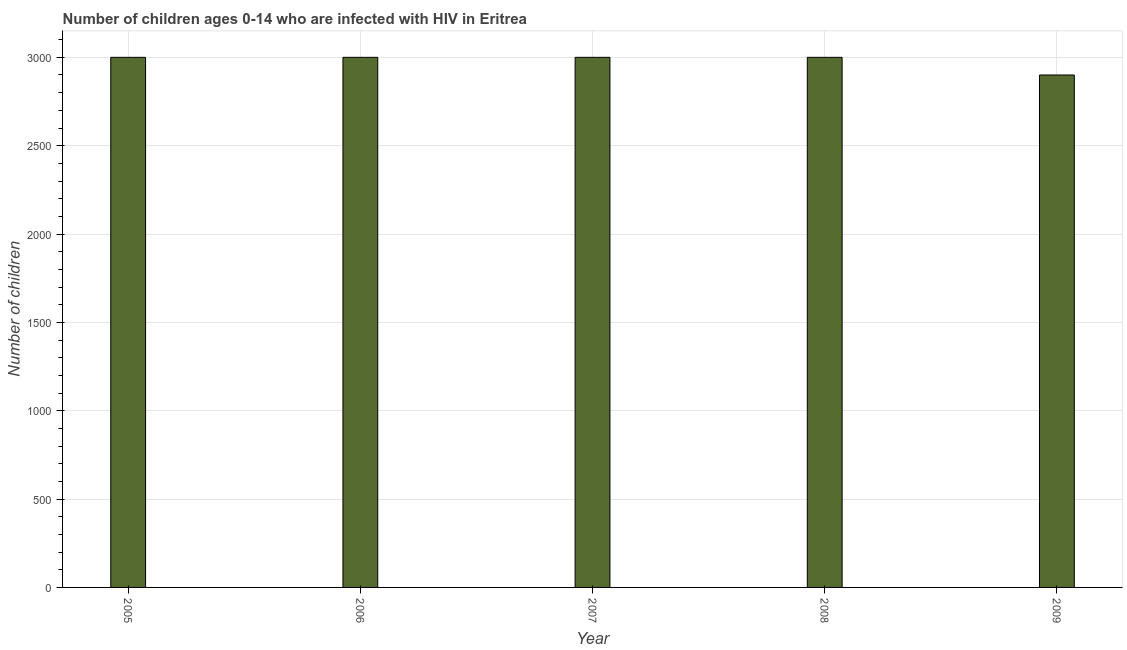Does the graph contain grids?
Keep it short and to the point. Yes. What is the title of the graph?
Make the answer very short. Number of children ages 0-14 who are infected with HIV in Eritrea. What is the label or title of the X-axis?
Offer a terse response. Year. What is the label or title of the Y-axis?
Your response must be concise. Number of children. What is the number of children living with hiv in 2009?
Ensure brevity in your answer.  2900. Across all years, what is the maximum number of children living with hiv?
Keep it short and to the point. 3000. Across all years, what is the minimum number of children living with hiv?
Provide a short and direct response. 2900. In which year was the number of children living with hiv maximum?
Give a very brief answer. 2005. What is the sum of the number of children living with hiv?
Your answer should be very brief. 1.49e+04. What is the average number of children living with hiv per year?
Your answer should be compact. 2980. What is the median number of children living with hiv?
Provide a succinct answer. 3000. What is the ratio of the number of children living with hiv in 2005 to that in 2009?
Your answer should be compact. 1.03. Is the number of children living with hiv in 2005 less than that in 2007?
Give a very brief answer. No. Is the sum of the number of children living with hiv in 2007 and 2008 greater than the maximum number of children living with hiv across all years?
Your response must be concise. Yes. What is the difference between the highest and the lowest number of children living with hiv?
Your answer should be very brief. 100. In how many years, is the number of children living with hiv greater than the average number of children living with hiv taken over all years?
Provide a short and direct response. 4. What is the difference between two consecutive major ticks on the Y-axis?
Provide a succinct answer. 500. What is the Number of children in 2005?
Your answer should be compact. 3000. What is the Number of children of 2006?
Your response must be concise. 3000. What is the Number of children in 2007?
Your answer should be very brief. 3000. What is the Number of children of 2008?
Offer a terse response. 3000. What is the Number of children of 2009?
Provide a short and direct response. 2900. What is the difference between the Number of children in 2005 and 2006?
Provide a short and direct response. 0. What is the difference between the Number of children in 2005 and 2007?
Your answer should be compact. 0. What is the difference between the Number of children in 2005 and 2009?
Provide a succinct answer. 100. What is the difference between the Number of children in 2006 and 2007?
Keep it short and to the point. 0. What is the difference between the Number of children in 2006 and 2008?
Make the answer very short. 0. What is the difference between the Number of children in 2006 and 2009?
Give a very brief answer. 100. What is the difference between the Number of children in 2008 and 2009?
Your response must be concise. 100. What is the ratio of the Number of children in 2005 to that in 2006?
Your answer should be very brief. 1. What is the ratio of the Number of children in 2005 to that in 2007?
Your response must be concise. 1. What is the ratio of the Number of children in 2005 to that in 2008?
Make the answer very short. 1. What is the ratio of the Number of children in 2005 to that in 2009?
Ensure brevity in your answer.  1.03. What is the ratio of the Number of children in 2006 to that in 2008?
Make the answer very short. 1. What is the ratio of the Number of children in 2006 to that in 2009?
Your response must be concise. 1.03. What is the ratio of the Number of children in 2007 to that in 2008?
Your answer should be very brief. 1. What is the ratio of the Number of children in 2007 to that in 2009?
Your answer should be very brief. 1.03. What is the ratio of the Number of children in 2008 to that in 2009?
Provide a short and direct response. 1.03. 